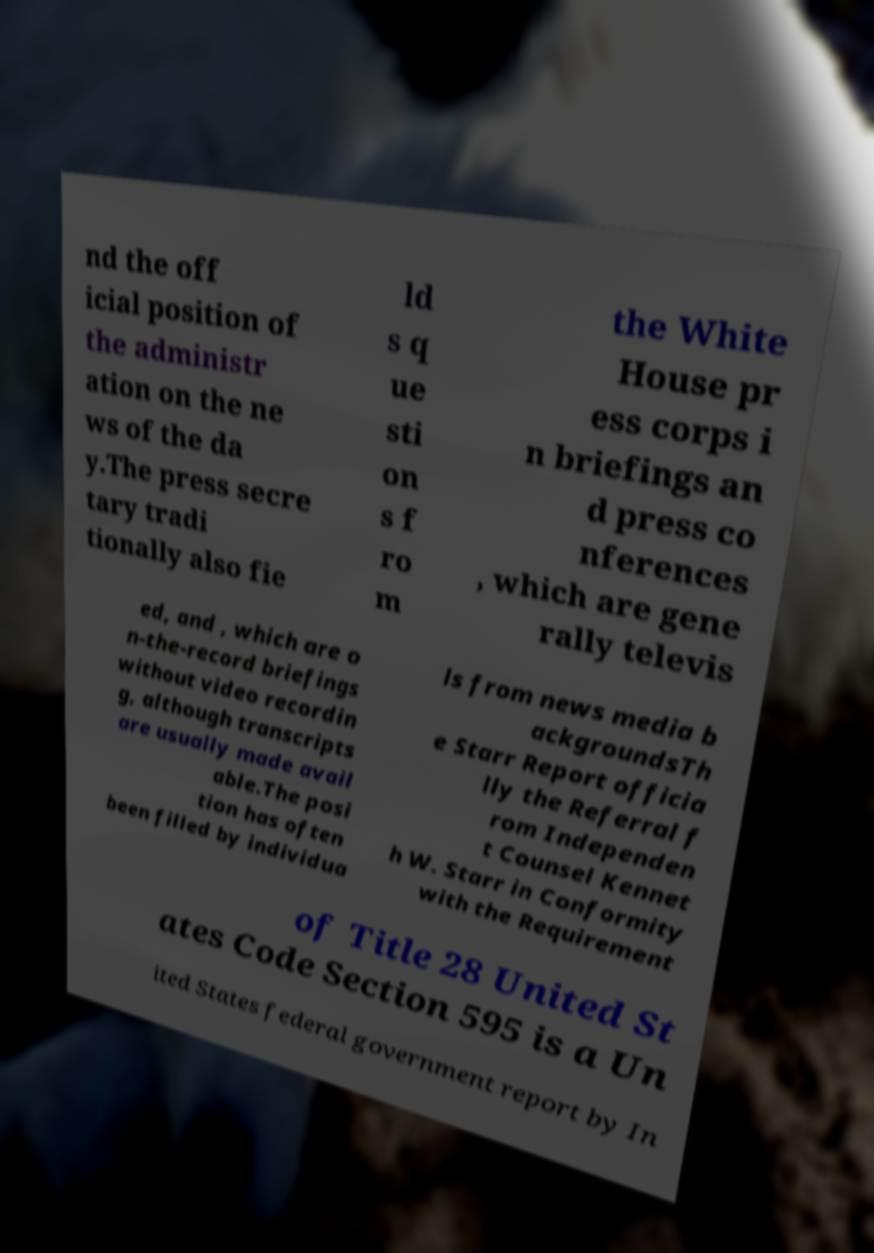Could you assist in decoding the text presented in this image and type it out clearly? nd the off icial position of the administr ation on the ne ws of the da y.The press secre tary tradi tionally also fie ld s q ue sti on s f ro m the White House pr ess corps i n briefings an d press co nferences , which are gene rally televis ed, and , which are o n-the-record briefings without video recordin g, although transcripts are usually made avail able.The posi tion has often been filled by individua ls from news media b ackgroundsTh e Starr Report officia lly the Referral f rom Independen t Counsel Kennet h W. Starr in Conformity with the Requirement of Title 28 United St ates Code Section 595 is a Un ited States federal government report by In 